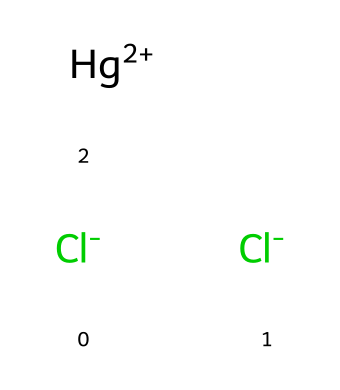What is the molecular formula of mercury(II) chloride? The SMILES representation indicates there are 1 mercury (Hg), 2 chlorine (Cl) atoms, leading to the empirical formula HgCl2.
Answer: HgCl2 How many total atoms are present in mercury(II) chloride? From the SMILES representation, we count 1 mercury atom and 2 chlorine atoms, which totals to 3 atoms.
Answer: 3 What is the oxidation state of mercury in this compound? In mercury(II) chloride, mercury has a +2 oxidation state, as indicated by the presence of [Hg+2] in the SMILES notation.
Answer: +2 What type of bond exists between mercury and chlorine in this compound? Mercury(II) chloride involves ionic bonding, as mercury donates electrons to the chlorine atoms, resulting in charged ions.
Answer: ionic Is mercury(II) chloride a solid or liquid at room temperature? Mercury(II) chloride is a solid at room temperature, known for being a white crystalline substance.
Answer: solid What potential health hazard is associated with mercury(II) chloride? Mercury(II) chloride is highly toxic, primarily affecting the nervous system, kidneys, and gastrointestinal tract upon exposure.
Answer: toxic What is the primary use of mercury(II) chloride in medical research? It is used as a laboratory reagent and in the synthesis of other compounds due to its effective properties in chemical reactions.
Answer: reagent 